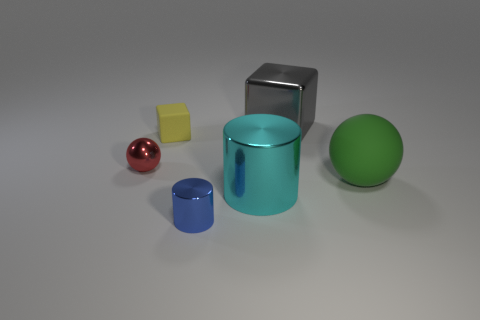Add 2 matte objects. How many objects exist? 8 Subtract all cylinders. How many objects are left? 4 Add 3 large red things. How many large red things exist? 3 Subtract 1 green spheres. How many objects are left? 5 Subtract all tiny blue cubes. Subtract all tiny cylinders. How many objects are left? 5 Add 1 small cubes. How many small cubes are left? 2 